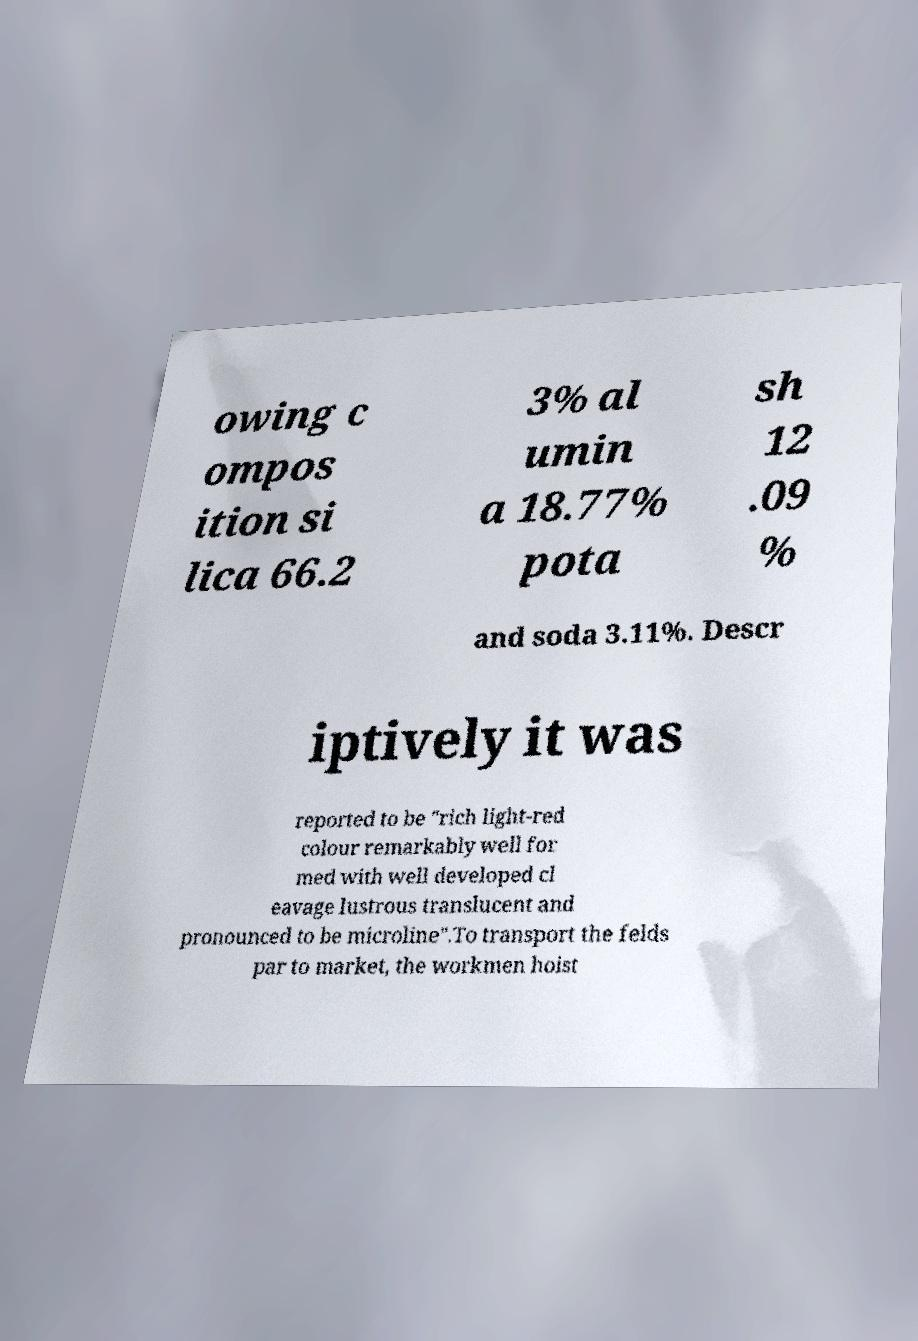Could you assist in decoding the text presented in this image and type it out clearly? owing c ompos ition si lica 66.2 3% al umin a 18.77% pota sh 12 .09 % and soda 3.11%. Descr iptively it was reported to be "rich light-red colour remarkably well for med with well developed cl eavage lustrous translucent and pronounced to be microline".To transport the felds par to market, the workmen hoist 